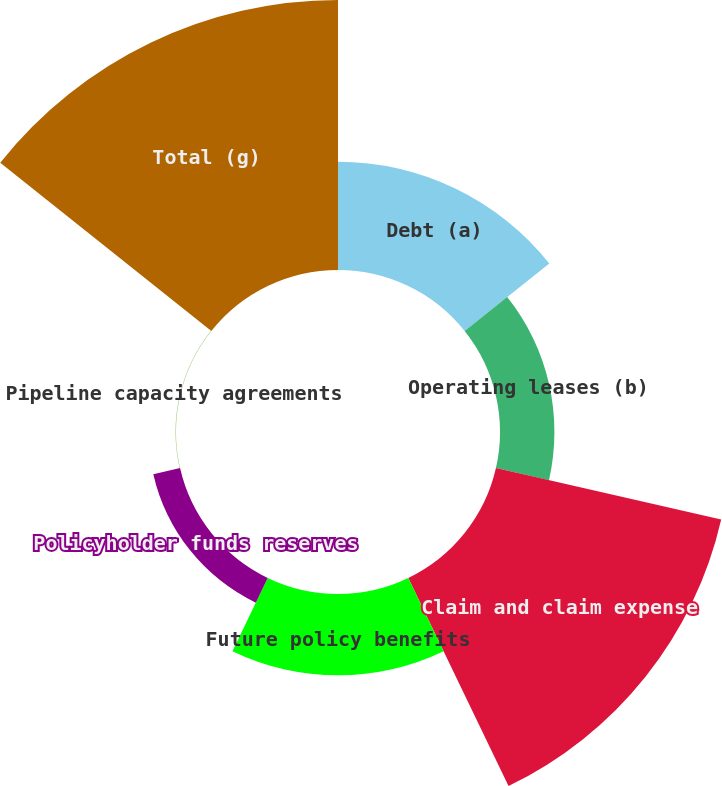<chart> <loc_0><loc_0><loc_500><loc_500><pie_chart><fcel>Debt (a)<fcel>Operating leases (b)<fcel>Claim and claim expense<fcel>Future policy benefits<fcel>Policyholder funds reserves<fcel>Pipeline capacity agreements<fcel>Total (g)<nl><fcel>14.01%<fcel>7.04%<fcel>29.89%<fcel>10.52%<fcel>3.55%<fcel>0.06%<fcel>34.93%<nl></chart> 